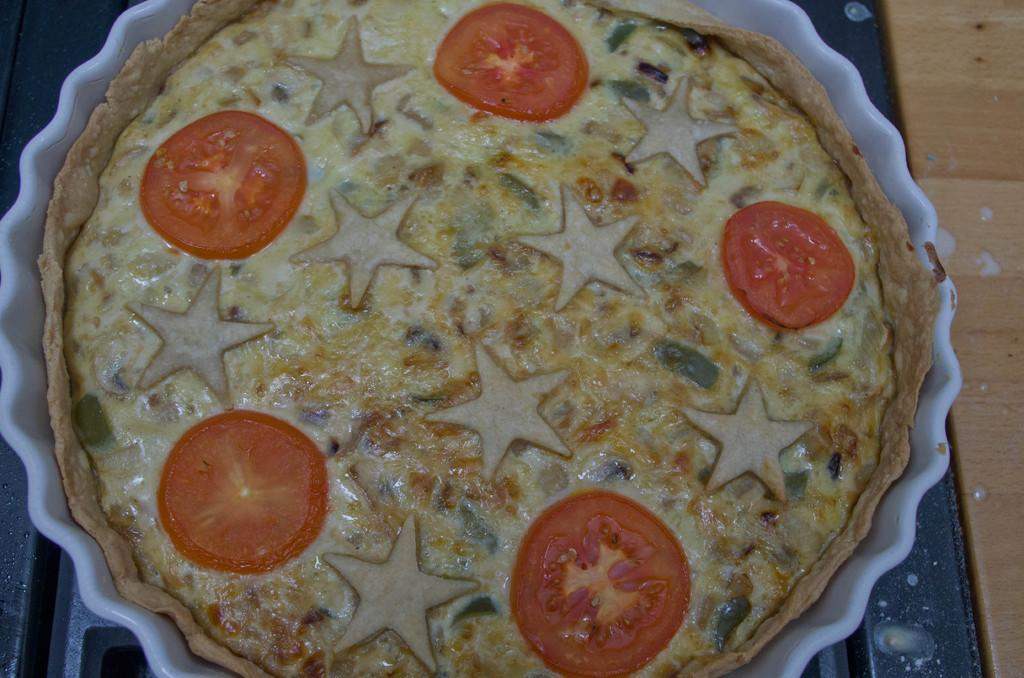What is the main subject in the foreground of the image? There is a food item in the foreground of the image. What is placed on the food item? Tomatoes are placed in a bowl on the food item. Can you describe the background of the image? The background includes a surface. How many boats can be seen sailing in the background of the image? There are no boats visible in the background of the image. What type of gun is being used to slice the tomatoes in the image? There is no gun present in the image; the tomatoes are placed in a bowl on the food item. 